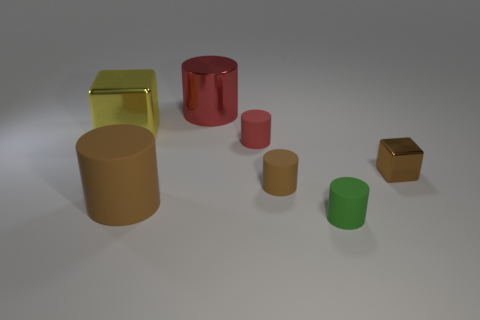How big is the brown metallic cube?
Keep it short and to the point. Small. Is the number of tiny brown metallic blocks on the left side of the tiny green rubber thing the same as the number of green cylinders?
Provide a succinct answer. No. How many other things are there of the same color as the large metal cylinder?
Your answer should be compact. 1. What color is the cylinder that is both in front of the small brown rubber thing and left of the small red thing?
Give a very brief answer. Brown. There is a brown rubber thing that is to the left of the small brown object in front of the metallic thing on the right side of the tiny green matte cylinder; what size is it?
Make the answer very short. Large. What number of objects are either metal objects to the left of the big brown thing or matte cylinders on the left side of the big red object?
Provide a short and direct response. 2. There is a big matte object; what shape is it?
Offer a very short reply. Cylinder. What number of other things are there of the same material as the small block
Your answer should be very brief. 2. The other metallic thing that is the same shape as the tiny brown metal thing is what size?
Your answer should be compact. Large. The block that is on the right side of the tiny cylinder that is behind the block that is to the right of the small red rubber thing is made of what material?
Provide a succinct answer. Metal. 